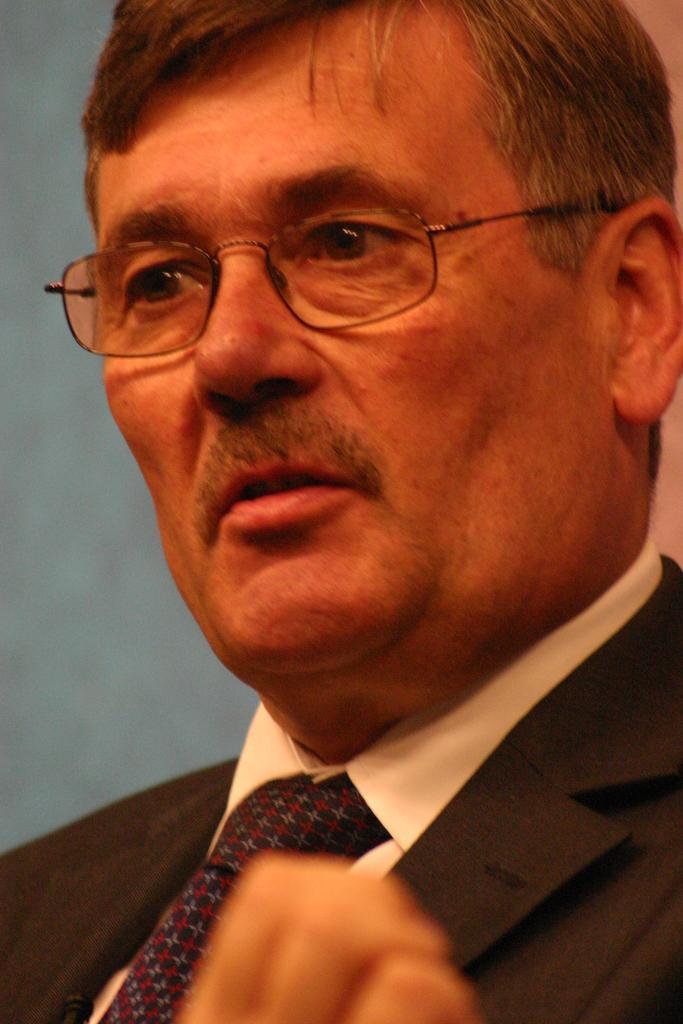Can you describe this image briefly? In this image we can see a man who is wearing white shirt, black coat, black tie and specks. 